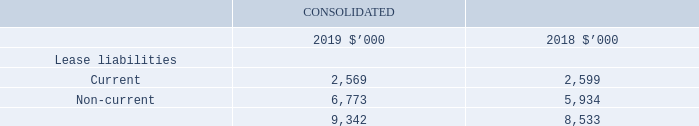3.5 Leases
Recognition, measurement and classification
The Group has applied AASB 16 using the retrospective approach. The impact of changes is disclosed in Note 1.6.
At inception of a contract, the Group assesses whether a contract is, or contains a lease. A contract is, or contains, a lease if the contract conveys the right to control the use of an identified asset for a period of time in exchange for consideration. To assess whether a contract conveys the right to control the use of an identified asset, the Group assesses whether:
• The contract involves the use of an identified asset – this may be specified explicitly or implicitly, and should be physically distinct or represent substantially all of the capacity of a physically distinct asset. If the supplier has a substantive substitution right, then the asset is not identified.
• The Group has the right to obtain substantially all of the economic benefits from the use of the asset throughout the period of use; and
• The Group has the right to direct the use of the asset. The Group has this right when it has the decisionmaking rights that are most relevant to changing how and for what purpose the asset is used. In rare cases where all the decisions about how and for what purpose the asset is used are predetermined, the Group has the right to direct the use of the asset if either:
• The Group has the right to operate the asset
•• The Group designed the asset in a way that predetermines how and for what purpose it will be used
The Group recognises a right-of-use asset and a lease liability at the lease commencement date. For measurement and recognition of right-of-use assets, refer to Note 3.1.
The lease liability is initially measured at the present value of the lease payments that are not paid at the commencement date, discounted using the interest rate implicit in the lease or, if that rate cannot be readily determined, the Group’s incremental borrowing rate. Generally, the Group uses its incremental borrowing rate as the discount rate.
Lease payments included in the measurement of the lease liability comprise:
• Fixed payments, including in-substance fixed payments;
• variable lease payments that depend on an index or a rate, initially measured using the index or rate as at the commencement date;
• amounts expected to be payable under a residual value guarantee; and
• the exercise price under a purchase option that the Group is reasonably certain to exercise, lease payments in an optional renewal period if the Group is reasonably certain to exercise an extension option, and penalties for early termination of a lease unless the Group is reasonably certain not to terminate early.
The lease liability is measured at amortised cost using the effective interest method. It is remeasured when there is a change in future lease payments arising from a change in an index or rate, if there is a change in the Group’s estimate of the amount expected to be payable under a residual value guarantee or if the Group changes its assessment of whether it will exercise a purchase, extension or termination option.
When the lease liability is remeasured in this way, a corresponding adjustment is made to the carrying amount of the right-of-use asset, or is recorded in profit or loss if the carrying amount of the right-of-use asset has been reduced to zero.
Short-term leases and leases of low-value assets
The Group has elected not to recognise right-of-use assets and lease liabilities for short-term leases of machinery that have a lease term of 12 months or less and leases of low-value assets, including IT equipment. The Group recognises the lease payments associated with these leases as an expense on a straight-line basis over the lease term.
What is the current lease liabilities for 2019?
Answer scale should be: thousand. 2,569. How is the lease liability measured? At amortised cost using the effective interest method. How does the Group recognise the lease payments assoictaed with short-term leases? As an expense on a straight-line basis over the lease term. What is the percentage change in the current lease liabilities from 2018 to 2019?
Answer scale should be: percent. (2,569-2,599)/2,599
Answer: -0.01. What is the percentage change in the non-current lease liabilities from 2018 to 2019?
Answer scale should be: percent. (6,773-5,934)/5,934
Answer: 14.14. What is the percentage change in the total lease liabilities from 2018 to 2019?
Answer scale should be: percent. (9,342-8,533)/8,533
Answer: 9.48. 